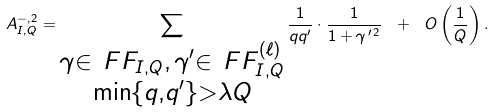<formula> <loc_0><loc_0><loc_500><loc_500>A _ { I , Q } ^ { - , 2 } = \sum _ { \substack { \gamma \in \ F F _ { I , Q } , \, \gamma ^ { \prime } \in \ F F _ { I , Q } ^ { ( \ell ) } \\ \min \{ q , q ^ { \prime } \} > \lambda Q } } \frac { 1 } { q q ^ { \prime } } \cdot \frac { 1 } { 1 + \gamma ^ { \, \prime \, 2 } } \ + \ O \left ( \frac { 1 } { Q } \right ) .</formula> 